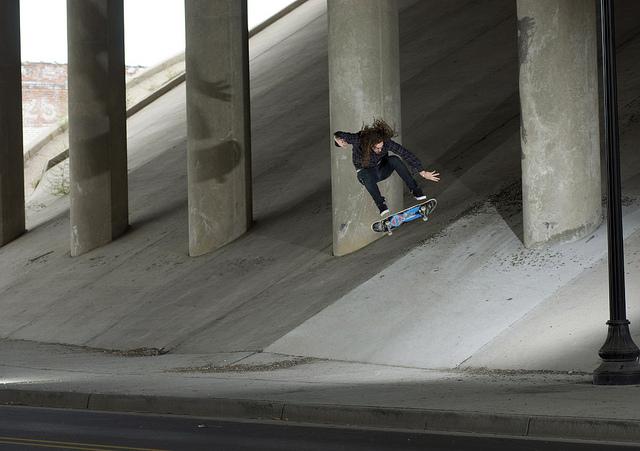Is this a professional event?
Keep it brief. No. How many babies are there?
Concise answer only. 0. Is his hair long?
Answer briefly. Yes. Is this person high in the air?
Concise answer only. Yes. 